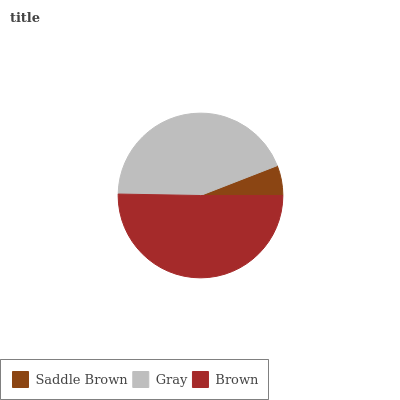Is Saddle Brown the minimum?
Answer yes or no. Yes. Is Brown the maximum?
Answer yes or no. Yes. Is Gray the minimum?
Answer yes or no. No. Is Gray the maximum?
Answer yes or no. No. Is Gray greater than Saddle Brown?
Answer yes or no. Yes. Is Saddle Brown less than Gray?
Answer yes or no. Yes. Is Saddle Brown greater than Gray?
Answer yes or no. No. Is Gray less than Saddle Brown?
Answer yes or no. No. Is Gray the high median?
Answer yes or no. Yes. Is Gray the low median?
Answer yes or no. Yes. Is Saddle Brown the high median?
Answer yes or no. No. Is Brown the low median?
Answer yes or no. No. 